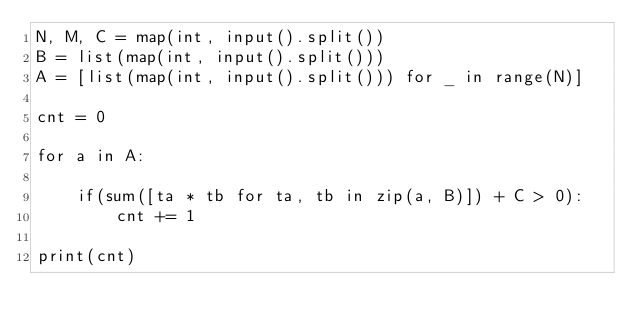<code> <loc_0><loc_0><loc_500><loc_500><_Python_>N, M, C = map(int, input().split())
B = list(map(int, input().split()))
A = [list(map(int, input().split())) for _ in range(N)]

cnt = 0

for a in A:
    
    if(sum([ta * tb for ta, tb in zip(a, B)]) + C > 0):
        cnt += 1

print(cnt)</code> 